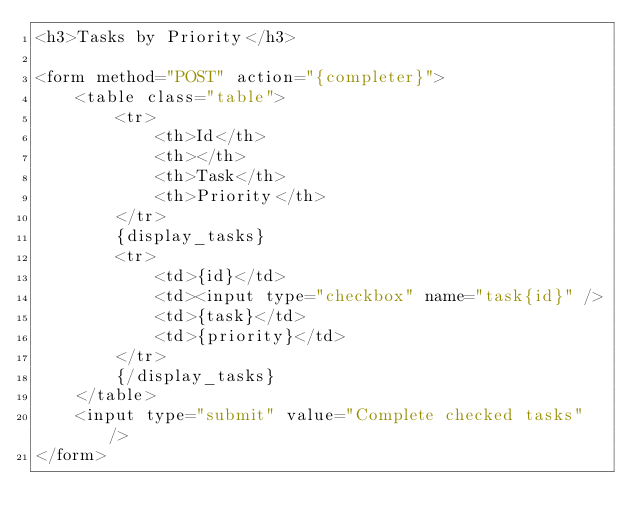Convert code to text. <code><loc_0><loc_0><loc_500><loc_500><_PHP_><h3>Tasks by Priority</h3>

<form method="POST" action="{completer}">
    <table class="table">
        <tr>
            <th>Id</th>
            <th></th>
            <th>Task</th>
            <th>Priority</th>
        </tr>
        {display_tasks}
        <tr>
            <td>{id}</td>
            <td><input type="checkbox" name="task{id}" />
            <td>{task}</td>
            <td>{priority}</td>
        </tr>
        {/display_tasks}    
    </table>
    <input type="submit" value="Complete checked tasks" />
</form></code> 